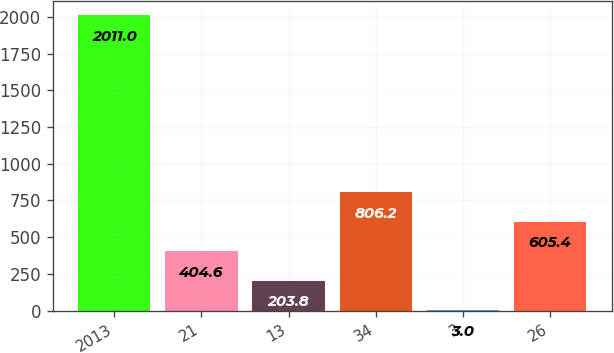Convert chart to OTSL. <chart><loc_0><loc_0><loc_500><loc_500><bar_chart><fcel>2013<fcel>21<fcel>13<fcel>34<fcel>3<fcel>26<nl><fcel>2011<fcel>404.6<fcel>203.8<fcel>806.2<fcel>3<fcel>605.4<nl></chart> 